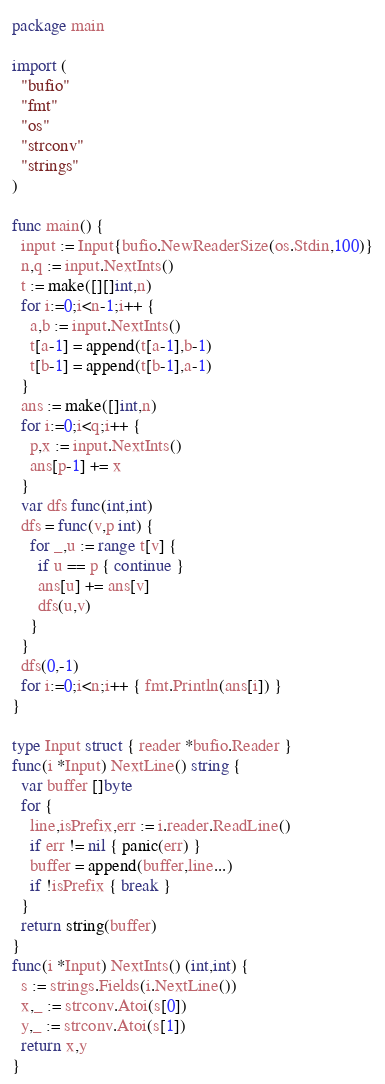<code> <loc_0><loc_0><loc_500><loc_500><_Go_>package main

import (
  "bufio"
  "fmt"
  "os"
  "strconv"
  "strings"
)

func main() {
  input := Input{bufio.NewReaderSize(os.Stdin,100)}
  n,q := input.NextInts()
  t := make([][]int,n)
  for i:=0;i<n-1;i++ {
    a,b := input.NextInts()
    t[a-1] = append(t[a-1],b-1)
    t[b-1] = append(t[b-1],a-1)
  }
  ans := make([]int,n)
  for i:=0;i<q;i++ {
    p,x := input.NextInts()
    ans[p-1] += x
  }
  var dfs func(int,int)
  dfs = func(v,p int) {
    for _,u := range t[v] {
      if u == p { continue }
      ans[u] += ans[v]
      dfs(u,v)
    }
  }
  dfs(0,-1)
  for i:=0;i<n;i++ { fmt.Println(ans[i]) }
}

type Input struct { reader *bufio.Reader }
func(i *Input) NextLine() string {
  var buffer []byte
  for {
    line,isPrefix,err := i.reader.ReadLine()
    if err != nil { panic(err) }
    buffer = append(buffer,line...)
    if !isPrefix { break }
  }
  return string(buffer)
}
func(i *Input) NextInts() (int,int) {
  s := strings.Fields(i.NextLine())
  x,_ := strconv.Atoi(s[0])
  y,_ := strconv.Atoi(s[1])
  return x,y
}</code> 